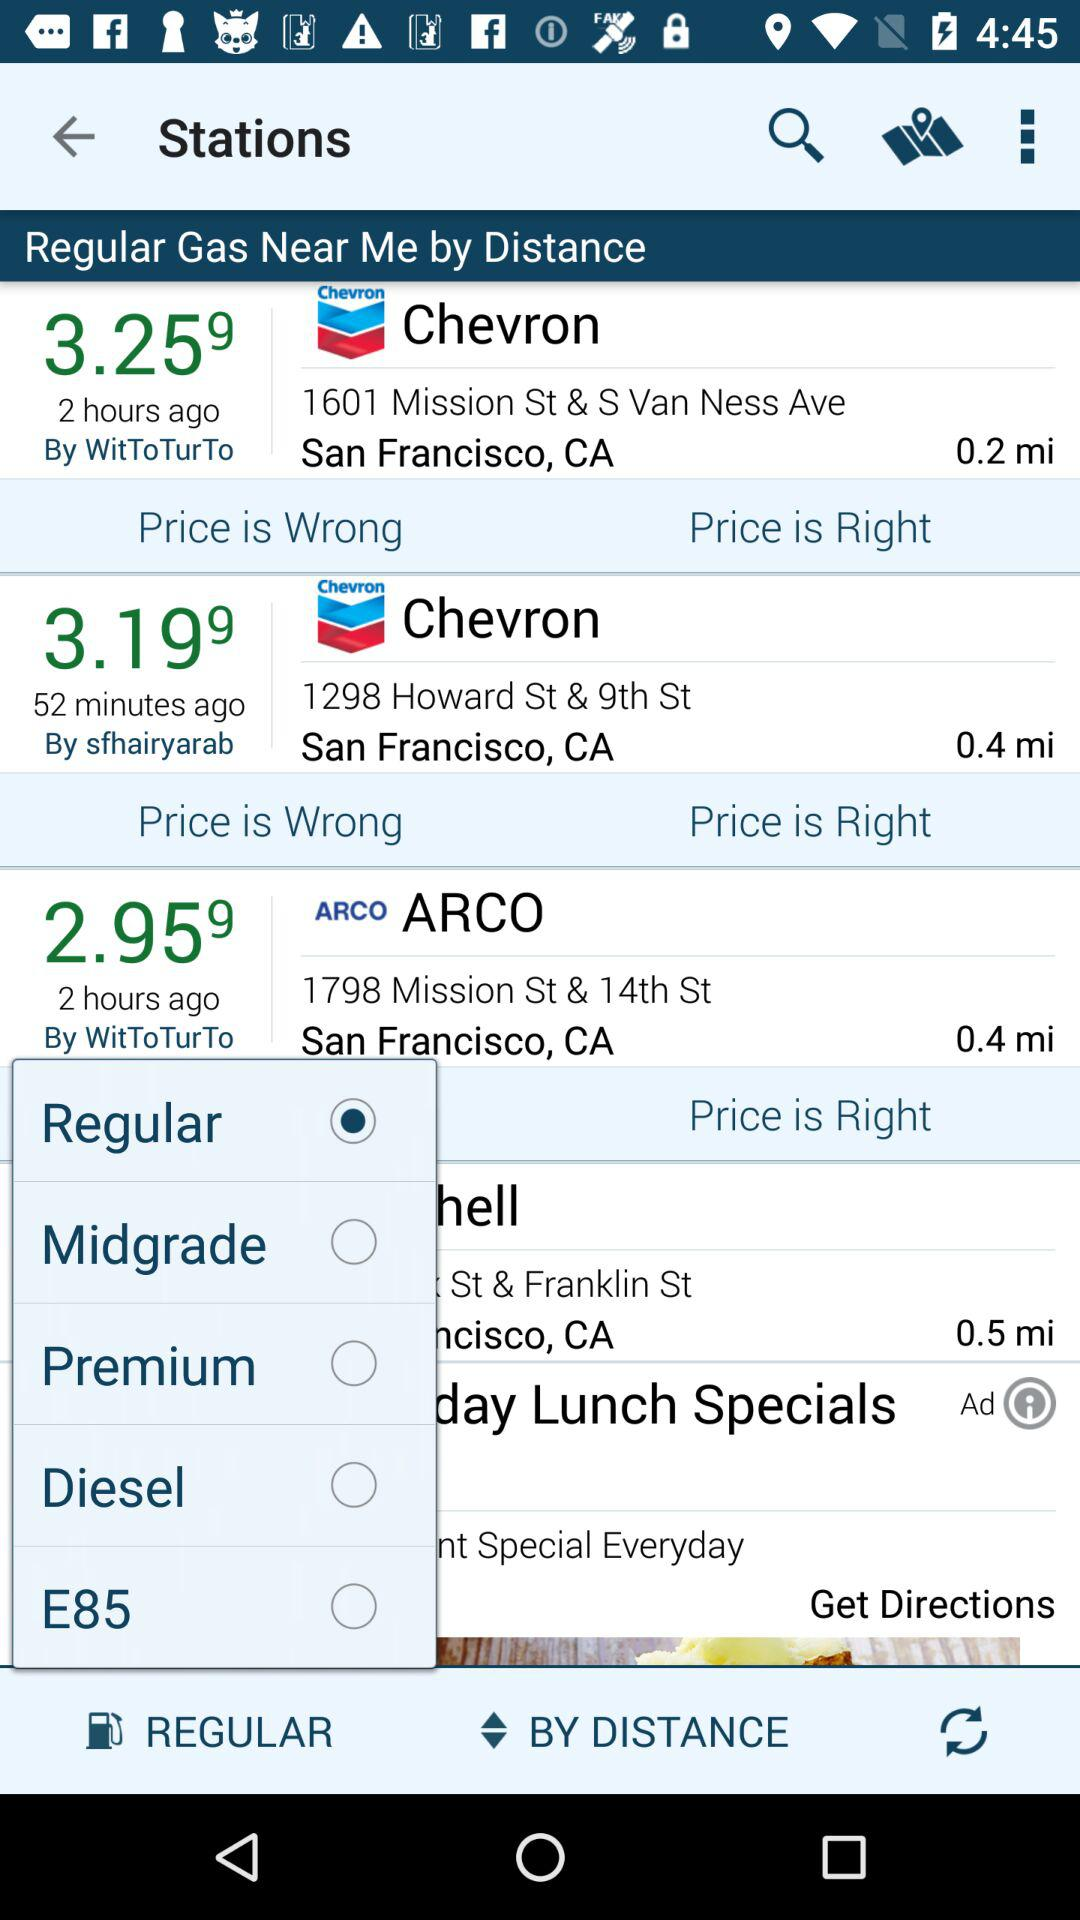What is the address of ARCO? The address is 1798 Mission St & 14th St, San Francisco, CA. 